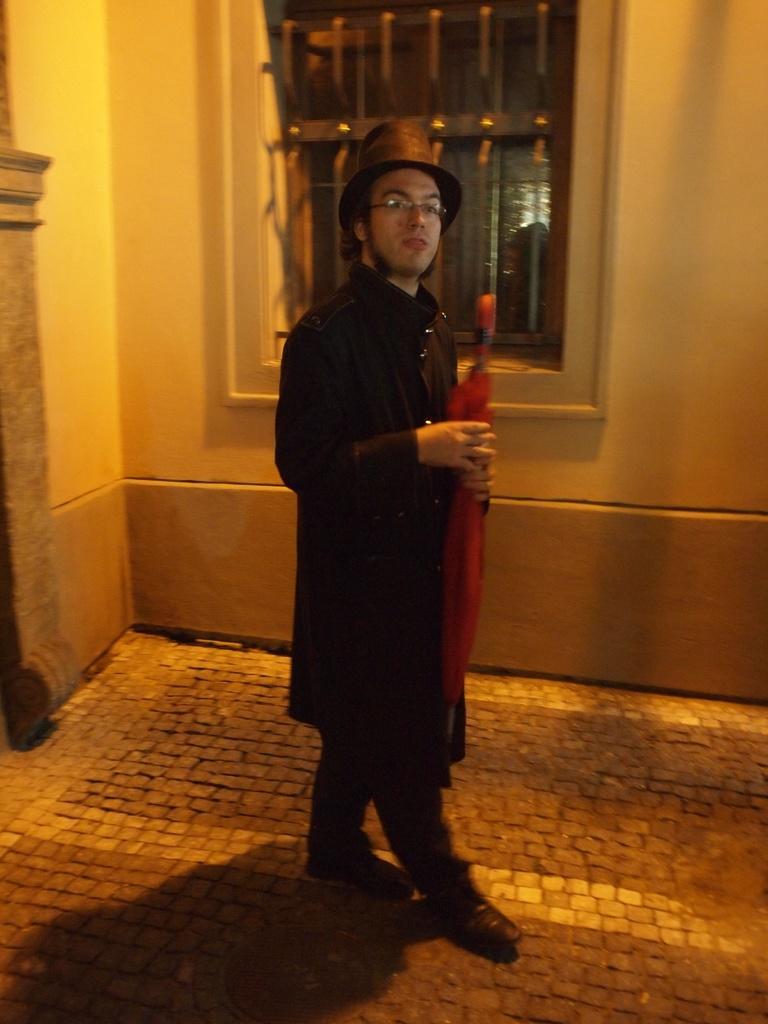How would you summarize this image in a sentence or two? In the image we can see a man standing, wearing clothes, hat, spectacles and the man is holding an object in hand. Here we can see the floor, wall and the window. 